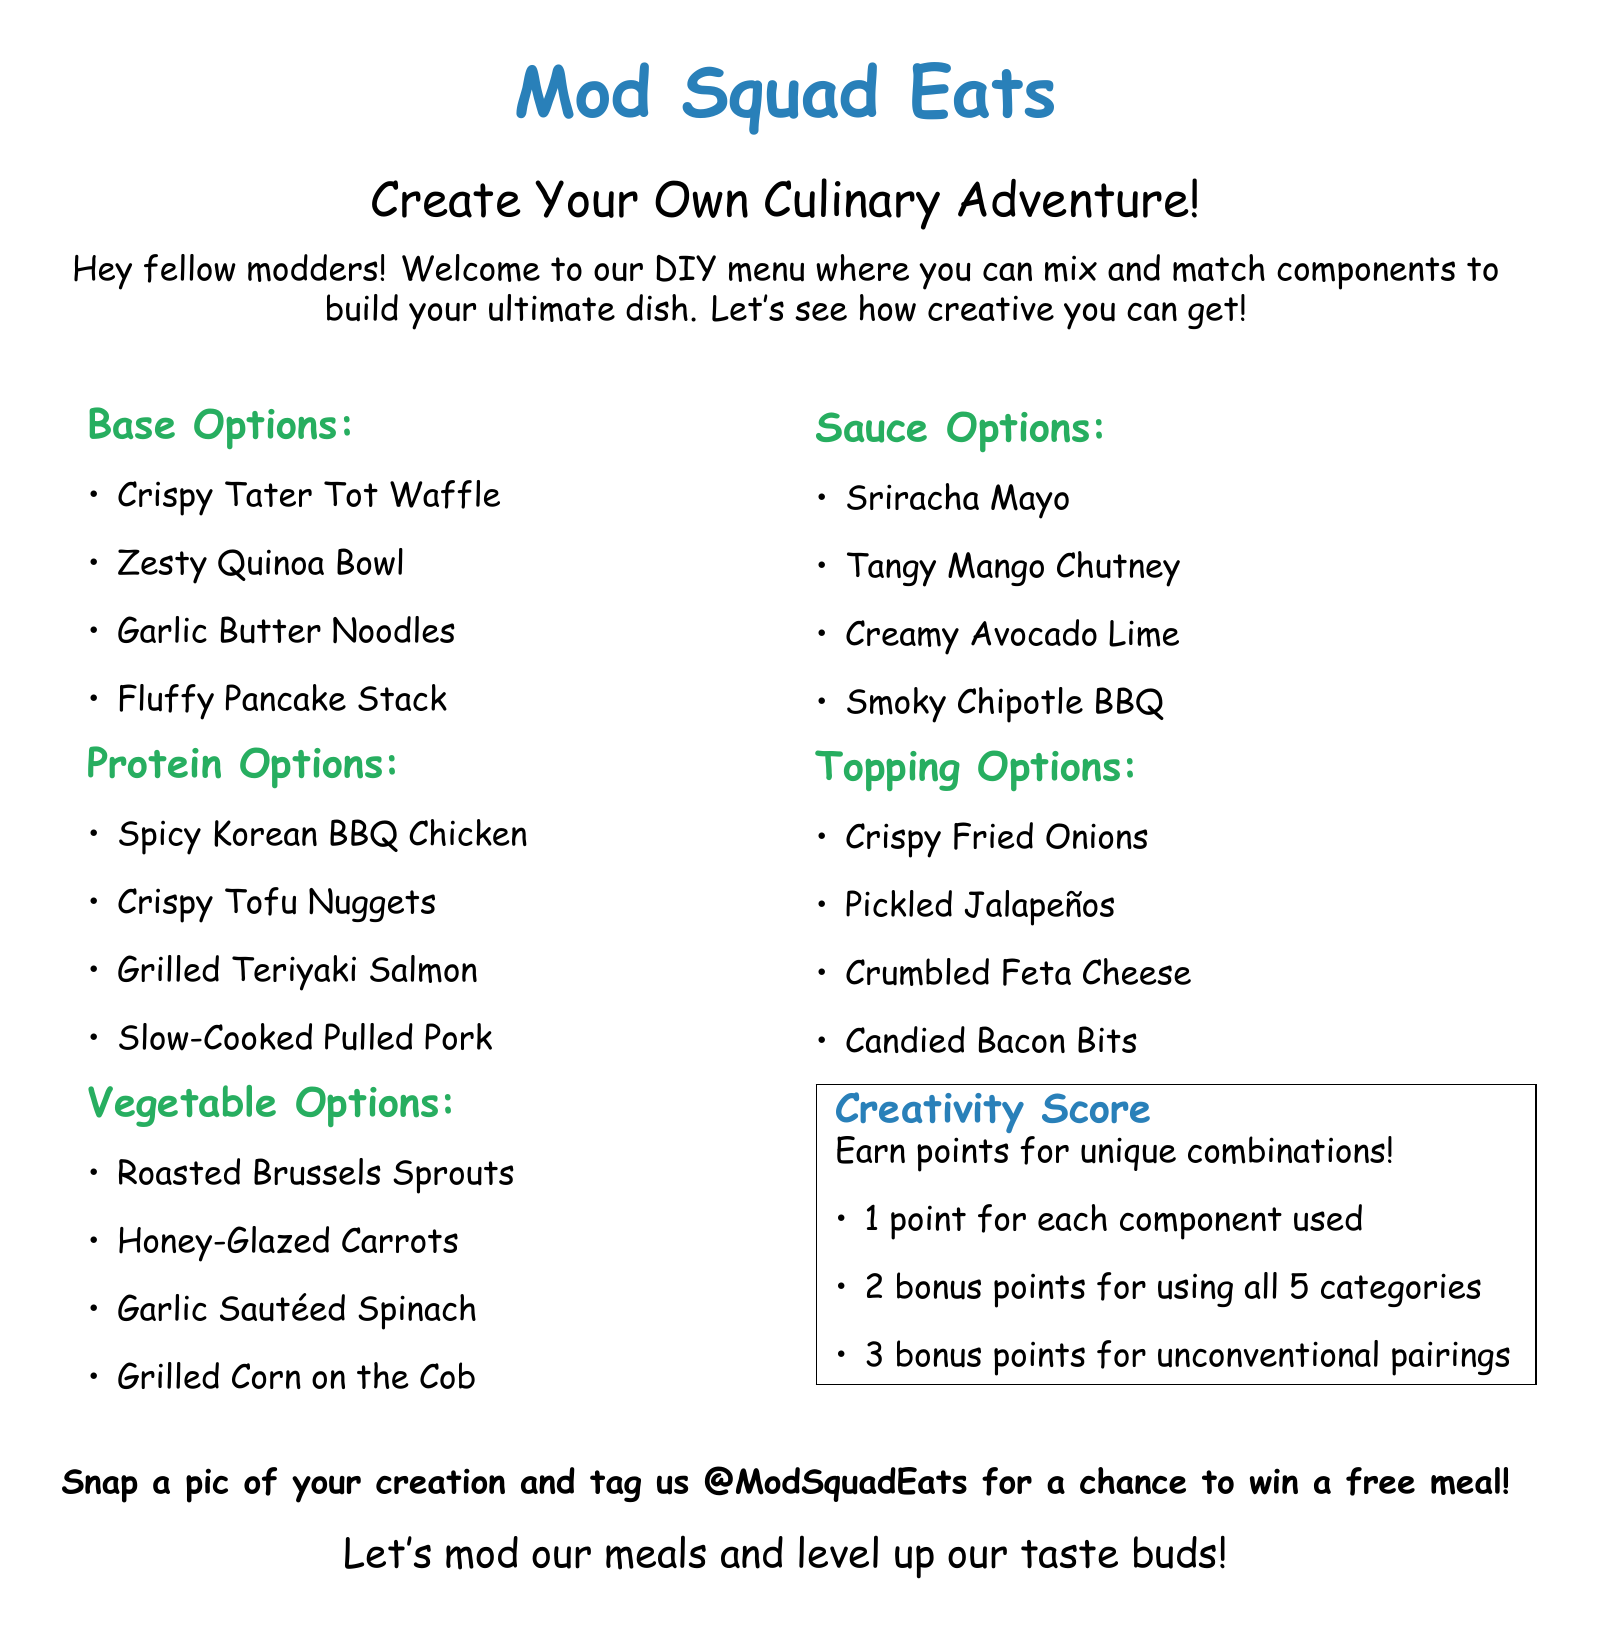What is the name of the DIY menu? The title of the menu is mentioned at the top of the document.
Answer: Mod Squad Eats How many base options are there? The number of base options is listed in the Base Options section.
Answer: 4 What is one of the protein options? The document lists several protein options.
Answer: Spicy Korean BBQ Chicken What do you earn for using all 5 categories? The incentive for using all categories is noted in the Creativity Score section.
Answer: 2 bonus points How many topping options are available? The document specifies the number of topping options listed.
Answer: 4 What is rewarded for unconventional pairings? The Creativity Score section explains the reward for unique combinations.
Answer: 3 bonus points What should you do with a picture of your creation? Instructions about the picture are given in the last part of the document.
Answer: Tag us @ModSquadEats What is the font used in the document? The font is specified at the beginning of the document in the code.
Answer: Comic Sans MS 